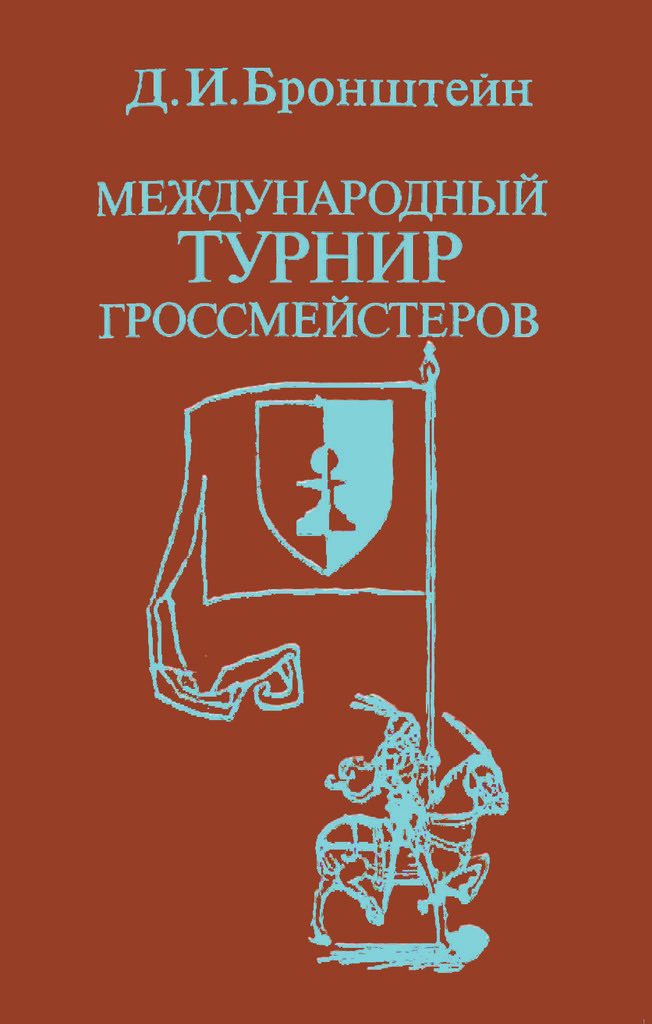Describe this image in one or two sentences. In this image there is a poster, on that poster there is a horse, on that horse there is a man holding a flag, on the top there is some text written. 